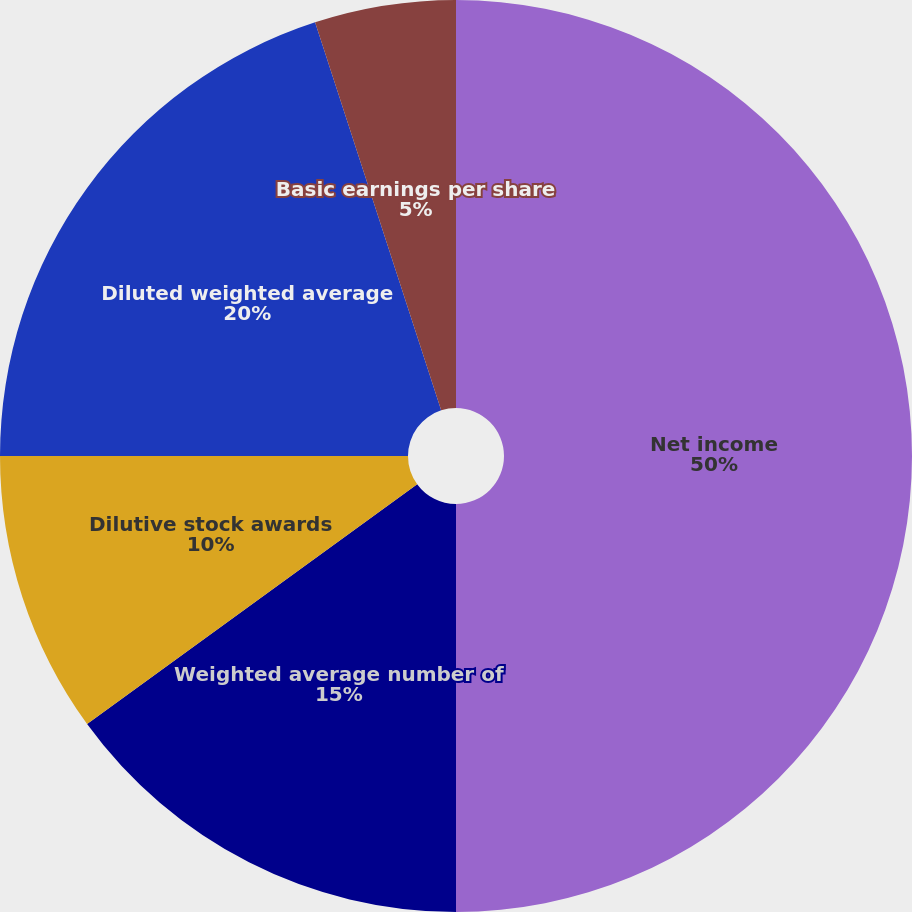Convert chart. <chart><loc_0><loc_0><loc_500><loc_500><pie_chart><fcel>Net income<fcel>Weighted average number of<fcel>Dilutive stock awards<fcel>Diluted weighted average<fcel>Basic earnings per share<fcel>Diluted earnings per share<nl><fcel>50.0%<fcel>15.0%<fcel>10.0%<fcel>20.0%<fcel>5.0%<fcel>0.0%<nl></chart> 